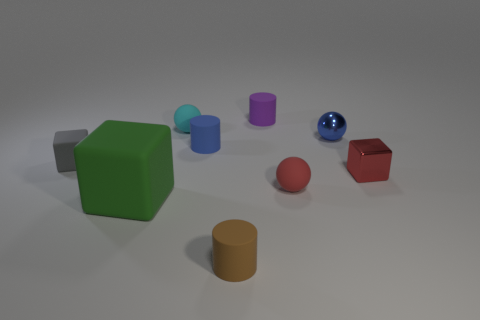How many tiny rubber things are the same color as the small metallic block?
Make the answer very short. 1. How many small objects are either red rubber objects or cyan objects?
Give a very brief answer. 2. What number of cyan objects have the same material as the small gray cube?
Provide a short and direct response. 1. How big is the rubber ball that is to the right of the cyan sphere?
Offer a terse response. Small. What shape is the tiny gray rubber thing behind the tiny matte object to the right of the purple cylinder?
Provide a succinct answer. Cube. How many small red objects are behind the small red object right of the small matte sphere in front of the red metallic object?
Provide a short and direct response. 0. Is the number of big rubber blocks behind the tiny cyan matte thing less than the number of large blue matte objects?
Provide a succinct answer. No. The rubber thing that is in front of the big green thing has what shape?
Provide a short and direct response. Cylinder. The small metallic thing left of the block on the right side of the blue object to the right of the tiny red rubber ball is what shape?
Make the answer very short. Sphere. How many things are either gray blocks or red blocks?
Provide a short and direct response. 2. 